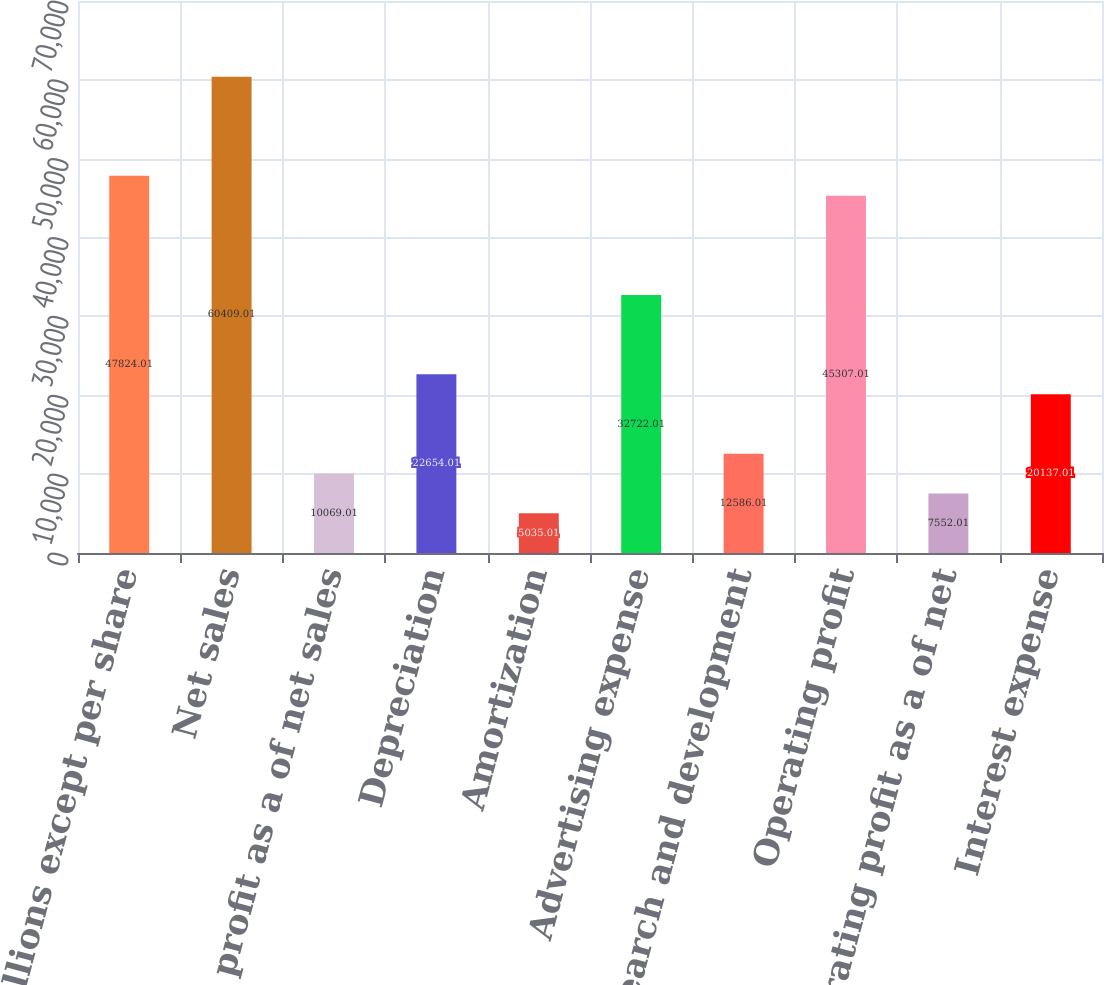Convert chart to OTSL. <chart><loc_0><loc_0><loc_500><loc_500><bar_chart><fcel>(in millions except per share<fcel>Net sales<fcel>Gross profit as a of net sales<fcel>Depreciation<fcel>Amortization<fcel>Advertising expense<fcel>Research and development<fcel>Operating profit<fcel>Operating profit as a of net<fcel>Interest expense<nl><fcel>47824<fcel>60409<fcel>10069<fcel>22654<fcel>5035.01<fcel>32722<fcel>12586<fcel>45307<fcel>7552.01<fcel>20137<nl></chart> 